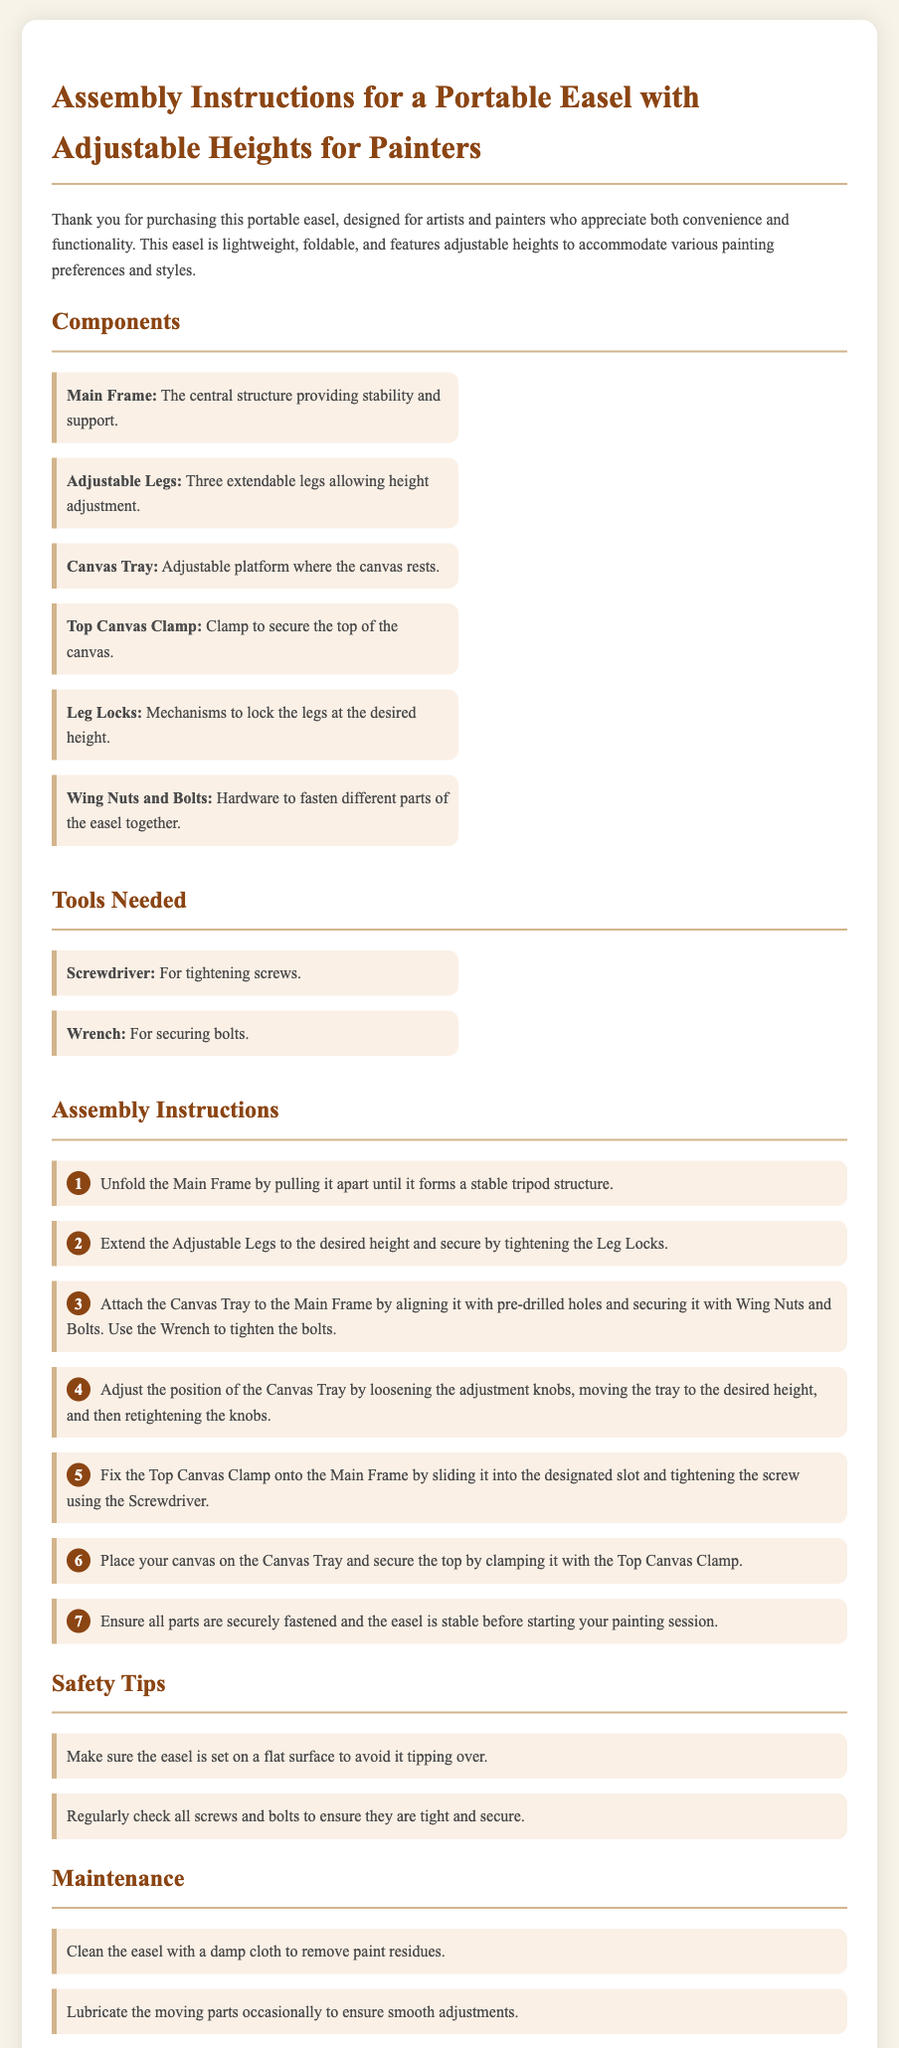What is the title of the document? The title of the document is prominently displayed at the top of the assembly instructions.
Answer: Assembly Instructions for a Portable Easel with Adjustable Heights for Painters What tool is needed to tighten screws? The document lists the necessary tools, including one specifically for tightening screws.
Answer: Screwdriver How many adjustable legs does the easel have? The document specifies the number of legs that allow for height adjustment.
Answer: Three What component secures the top of the canvas? The assembly instructions highlight a specific component used for securing the canvas.
Answer: Top Canvas Clamp What should you ensure before starting your painting session? The document emphasizes the importance of safety and stability before use.
Answer: All parts are securely fastened What is the first step in the assembly instructions? The initial step in the assembly process is clearly outlined in the instructions.
Answer: Unfold the Main Frame Why should the easel be placed on a flat surface? A safety tip explains the necessity of placing the easel correctly to prevent accidents.
Answer: To avoid tipping over What maintenance action is recommended for the easel? The maintenance section suggests a specific action to keep the easel clean.
Answer: Clean with a damp cloth Which hardware is used to fasten different parts of the easel? The document names hardware involved in assembling the easel.
Answer: Wing Nuts and Bolts 